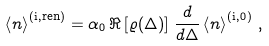Convert formula to latex. <formula><loc_0><loc_0><loc_500><loc_500>\left \langle n \right \rangle ^ { ( \text {i} , \text {ren} ) } = \alpha _ { 0 } \, \Re \left [ \varrho ( \Delta ) \right ] \, \frac { d } { d \Delta } \left \langle n \right \rangle ^ { ( \text {i} , 0 ) } \, ,</formula> 